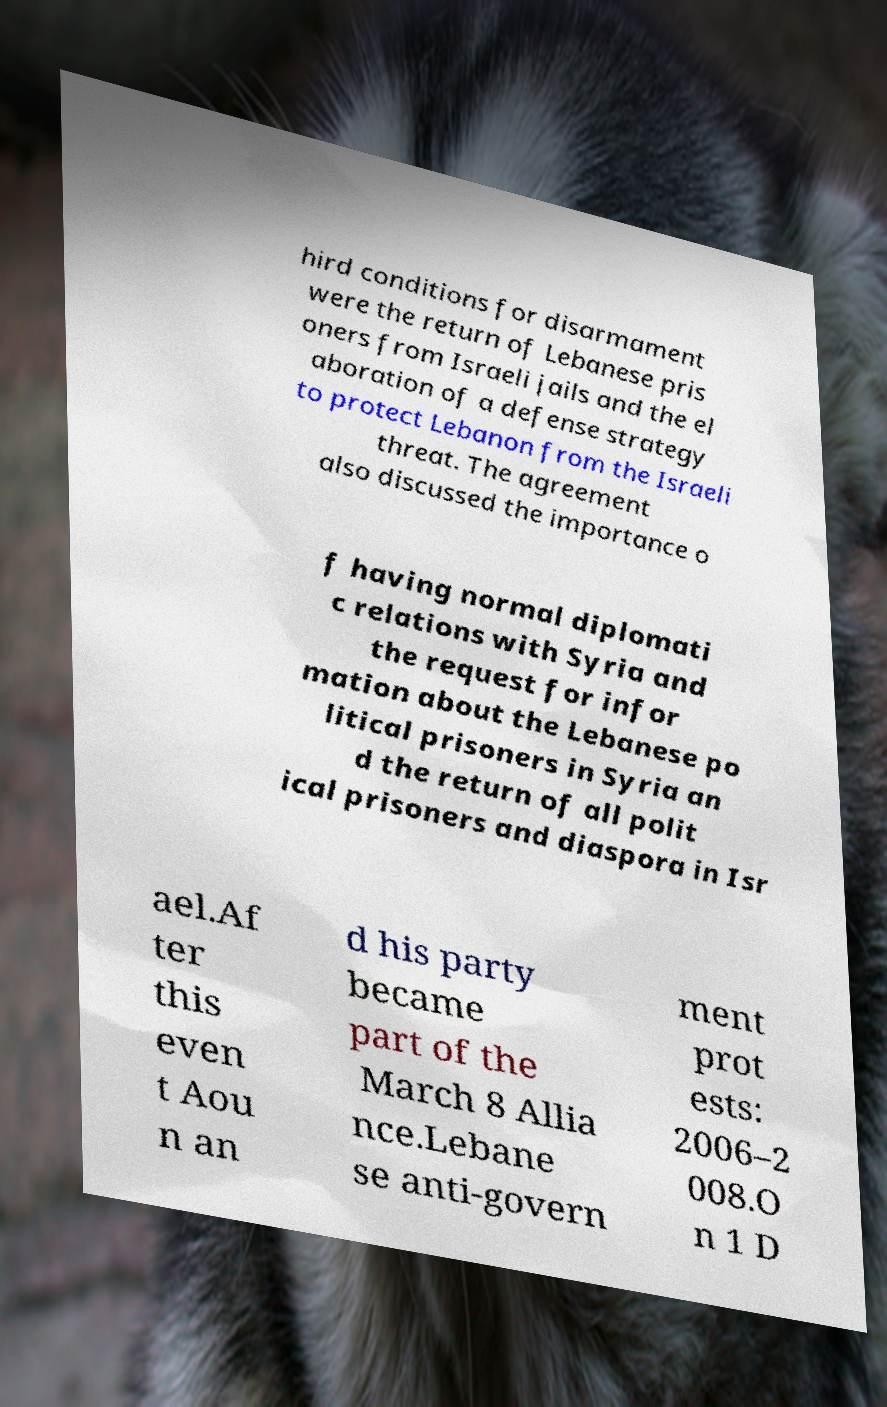Can you accurately transcribe the text from the provided image for me? hird conditions for disarmament were the return of Lebanese pris oners from Israeli jails and the el aboration of a defense strategy to protect Lebanon from the Israeli threat. The agreement also discussed the importance o f having normal diplomati c relations with Syria and the request for infor mation about the Lebanese po litical prisoners in Syria an d the return of all polit ical prisoners and diaspora in Isr ael.Af ter this even t Aou n an d his party became part of the March 8 Allia nce.Lebane se anti-govern ment prot ests: 2006–2 008.O n 1 D 